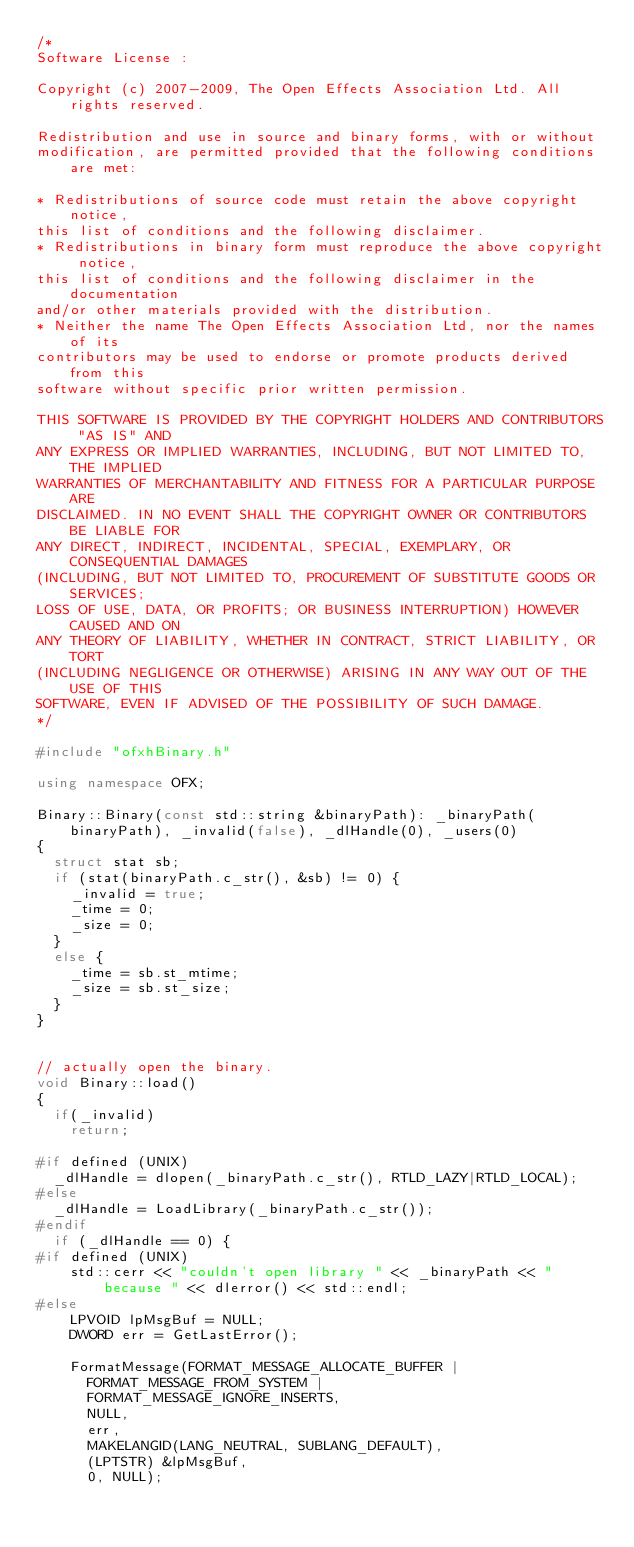<code> <loc_0><loc_0><loc_500><loc_500><_C++_>/*
Software License :

Copyright (c) 2007-2009, The Open Effects Association Ltd. All rights reserved.

Redistribution and use in source and binary forms, with or without
modification, are permitted provided that the following conditions are met:

* Redistributions of source code must retain the above copyright notice,
this list of conditions and the following disclaimer.
* Redistributions in binary form must reproduce the above copyright notice,
this list of conditions and the following disclaimer in the documentation
and/or other materials provided with the distribution.
* Neither the name The Open Effects Association Ltd, nor the names of its 
contributors may be used to endorse or promote products derived from this
software without specific prior written permission.

THIS SOFTWARE IS PROVIDED BY THE COPYRIGHT HOLDERS AND CONTRIBUTORS "AS IS" AND
ANY EXPRESS OR IMPLIED WARRANTIES, INCLUDING, BUT NOT LIMITED TO, THE IMPLIED
WARRANTIES OF MERCHANTABILITY AND FITNESS FOR A PARTICULAR PURPOSE ARE
DISCLAIMED. IN NO EVENT SHALL THE COPYRIGHT OWNER OR CONTRIBUTORS BE LIABLE FOR
ANY DIRECT, INDIRECT, INCIDENTAL, SPECIAL, EXEMPLARY, OR CONSEQUENTIAL DAMAGES
(INCLUDING, BUT NOT LIMITED TO, PROCUREMENT OF SUBSTITUTE GOODS OR SERVICES;
LOSS OF USE, DATA, OR PROFITS; OR BUSINESS INTERRUPTION) HOWEVER CAUSED AND ON
ANY THEORY OF LIABILITY, WHETHER IN CONTRACT, STRICT LIABILITY, OR TORT
(INCLUDING NEGLIGENCE OR OTHERWISE) ARISING IN ANY WAY OUT OF THE USE OF THIS
SOFTWARE, EVEN IF ADVISED OF THE POSSIBILITY OF SUCH DAMAGE.
*/

#include "ofxhBinary.h"

using namespace OFX;

Binary::Binary(const std::string &binaryPath): _binaryPath(binaryPath), _invalid(false), _dlHandle(0), _users(0)
{
  struct stat sb;
  if (stat(binaryPath.c_str(), &sb) != 0) {
    _invalid = true;
    _time = 0;
    _size = 0;
  } 
  else {
    _time = sb.st_mtime;
    _size = sb.st_size;
  }
}


// actually open the binary.
void Binary::load() 
{
  if(_invalid)
    return;

#if defined (UNIX)
  _dlHandle = dlopen(_binaryPath.c_str(), RTLD_LAZY|RTLD_LOCAL);
#else
  _dlHandle = LoadLibrary(_binaryPath.c_str());
#endif
  if (_dlHandle == 0) {
#if defined (UNIX)
    std::cerr << "couldn't open library " << _binaryPath << " because " << dlerror() << std::endl;
#else
    LPVOID lpMsgBuf = NULL;
    DWORD err = GetLastError();

    FormatMessage(FORMAT_MESSAGE_ALLOCATE_BUFFER |
      FORMAT_MESSAGE_FROM_SYSTEM |
      FORMAT_MESSAGE_IGNORE_INSERTS,
      NULL,
      err,
      MAKELANGID(LANG_NEUTRAL, SUBLANG_DEFAULT),
      (LPTSTR) &lpMsgBuf,
      0, NULL);
</code> 